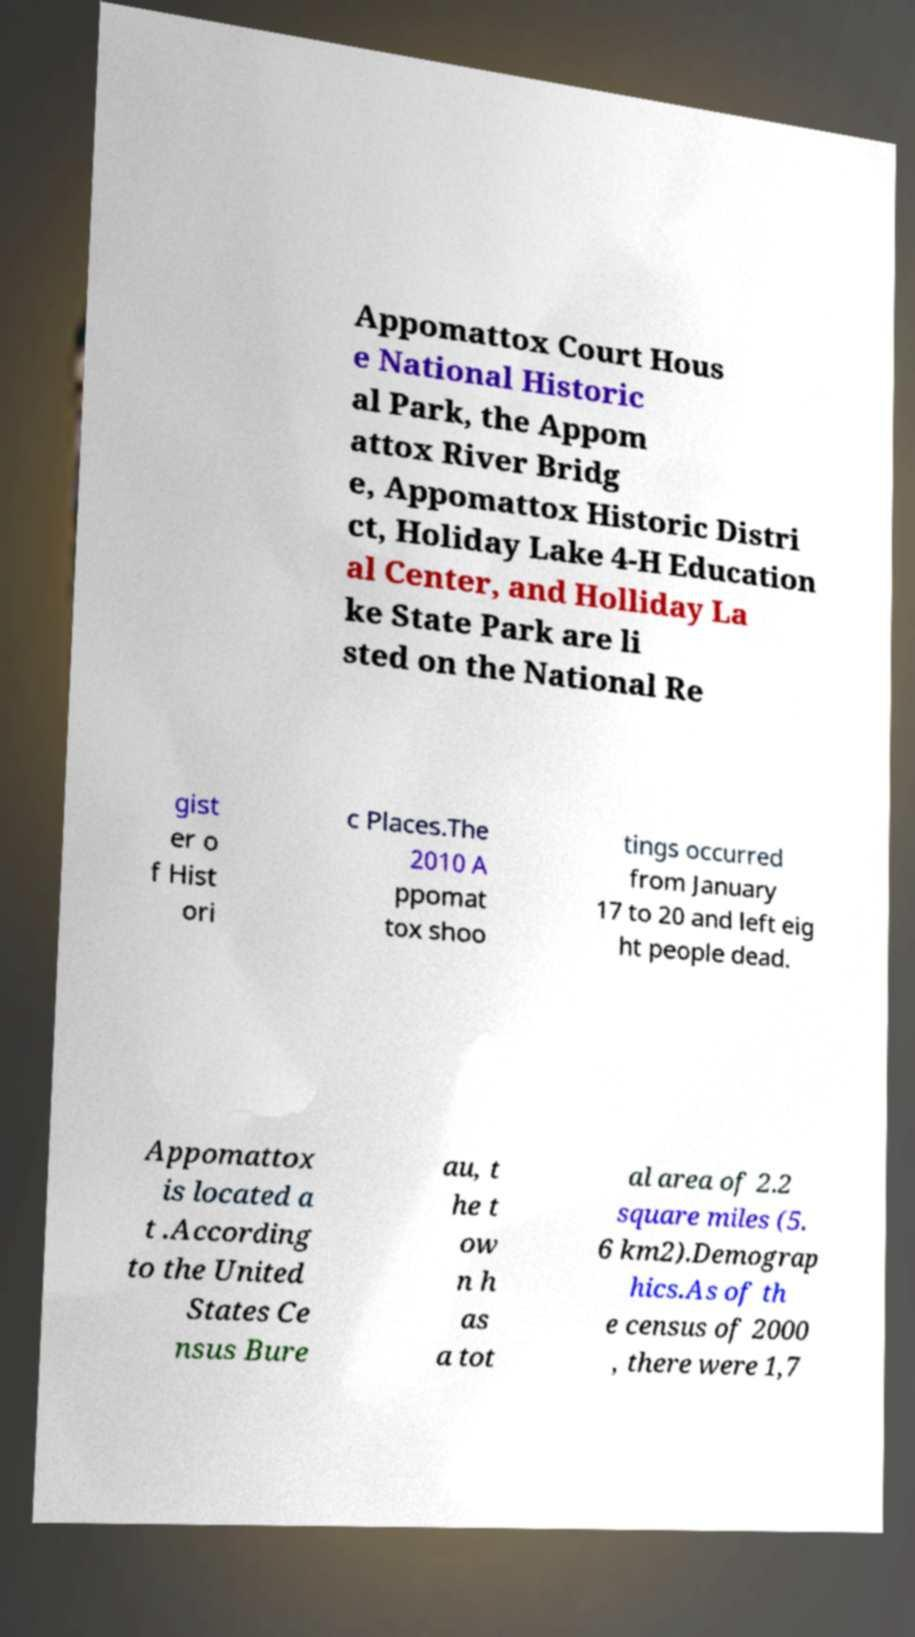What messages or text are displayed in this image? I need them in a readable, typed format. Appomattox Court Hous e National Historic al Park, the Appom attox River Bridg e, Appomattox Historic Distri ct, Holiday Lake 4-H Education al Center, and Holliday La ke State Park are li sted on the National Re gist er o f Hist ori c Places.The 2010 A ppomat tox shoo tings occurred from January 17 to 20 and left eig ht people dead. Appomattox is located a t .According to the United States Ce nsus Bure au, t he t ow n h as a tot al area of 2.2 square miles (5. 6 km2).Demograp hics.As of th e census of 2000 , there were 1,7 